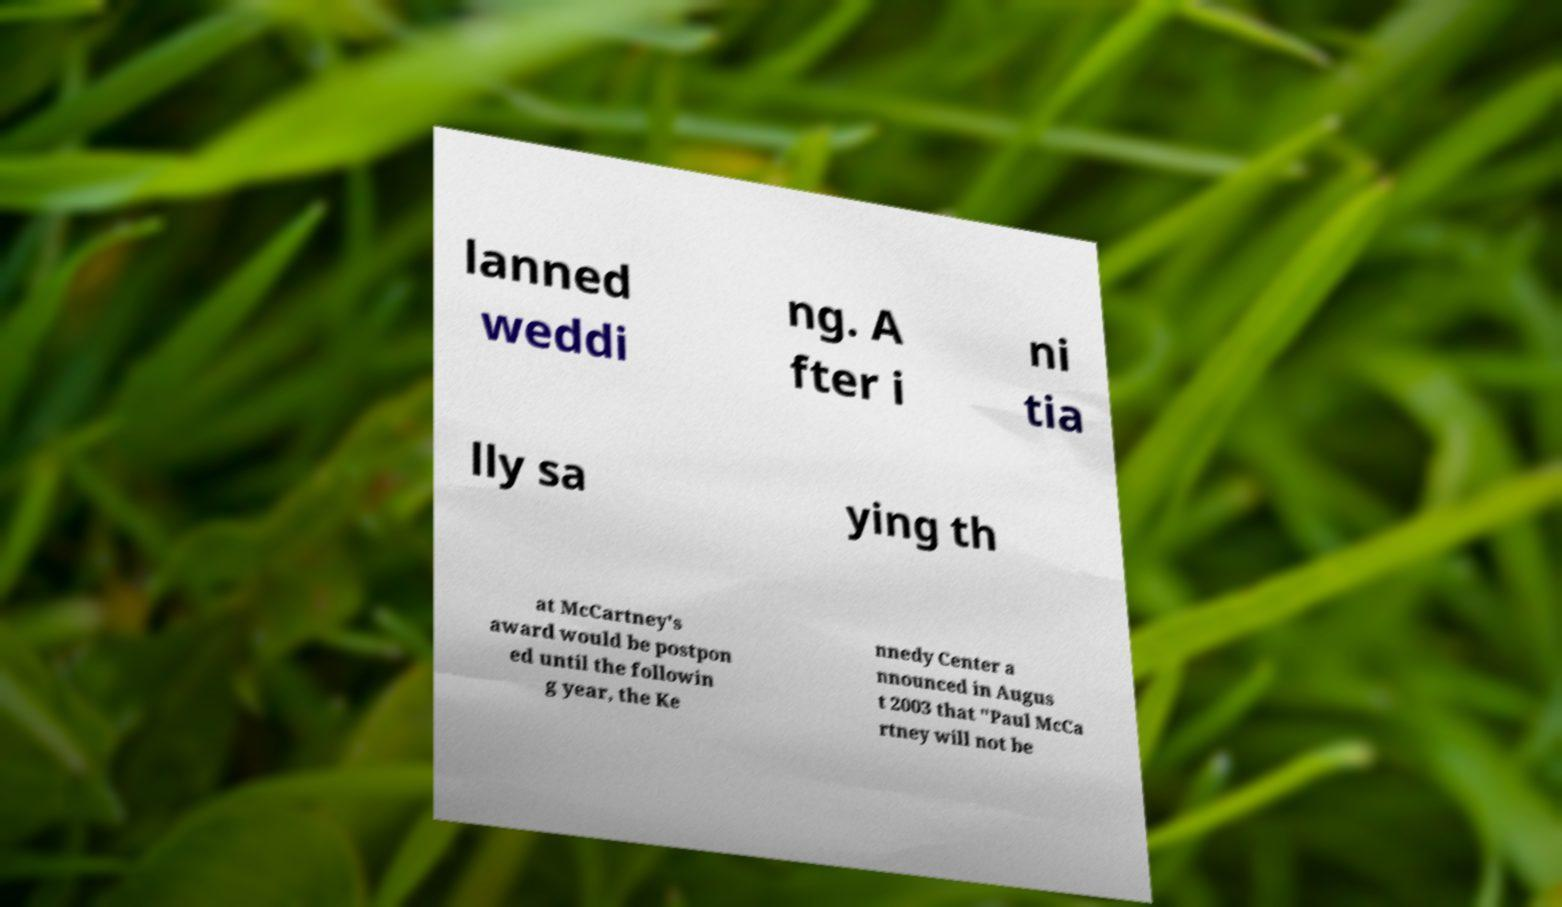For documentation purposes, I need the text within this image transcribed. Could you provide that? lanned weddi ng. A fter i ni tia lly sa ying th at McCartney's award would be postpon ed until the followin g year, the Ke nnedy Center a nnounced in Augus t 2003 that "Paul McCa rtney will not be 